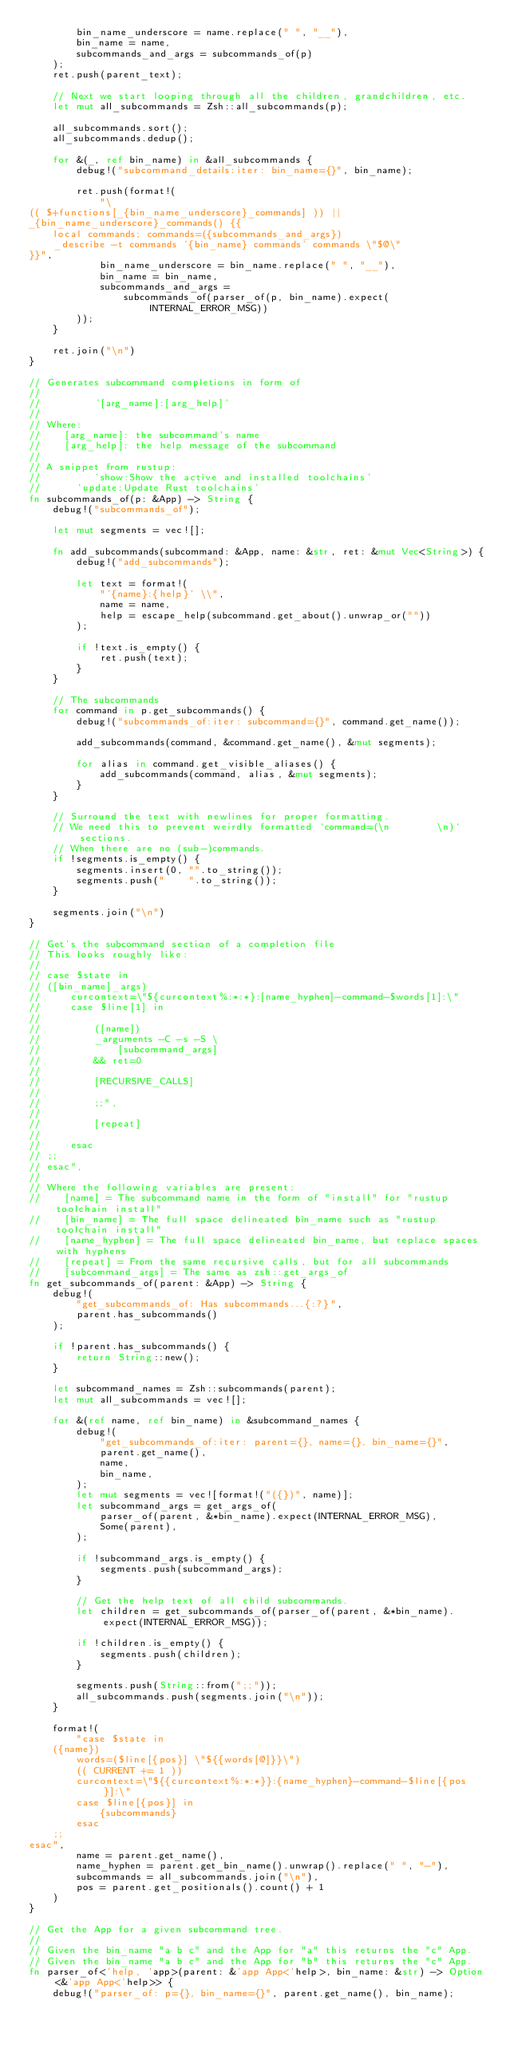Convert code to text. <code><loc_0><loc_0><loc_500><loc_500><_Rust_>        bin_name_underscore = name.replace(" ", "__"),
        bin_name = name,
        subcommands_and_args = subcommands_of(p)
    );
    ret.push(parent_text);

    // Next we start looping through all the children, grandchildren, etc.
    let mut all_subcommands = Zsh::all_subcommands(p);

    all_subcommands.sort();
    all_subcommands.dedup();

    for &(_, ref bin_name) in &all_subcommands {
        debug!("subcommand_details:iter: bin_name={}", bin_name);

        ret.push(format!(
            "\
(( $+functions[_{bin_name_underscore}_commands] )) ||
_{bin_name_underscore}_commands() {{
    local commands; commands=({subcommands_and_args})
    _describe -t commands '{bin_name} commands' commands \"$@\"
}}",
            bin_name_underscore = bin_name.replace(" ", "__"),
            bin_name = bin_name,
            subcommands_and_args =
                subcommands_of(parser_of(p, bin_name).expect(INTERNAL_ERROR_MSG))
        ));
    }

    ret.join("\n")
}

// Generates subcommand completions in form of
//
//         '[arg_name]:[arg_help]'
//
// Where:
//    [arg_name]: the subcommand's name
//    [arg_help]: the help message of the subcommand
//
// A snippet from rustup:
//         'show:Show the active and installed toolchains'
//      'update:Update Rust toolchains'
fn subcommands_of(p: &App) -> String {
    debug!("subcommands_of");

    let mut segments = vec![];

    fn add_subcommands(subcommand: &App, name: &str, ret: &mut Vec<String>) {
        debug!("add_subcommands");

        let text = format!(
            "'{name}:{help}' \\",
            name = name,
            help = escape_help(subcommand.get_about().unwrap_or(""))
        );

        if !text.is_empty() {
            ret.push(text);
        }
    }

    // The subcommands
    for command in p.get_subcommands() {
        debug!("subcommands_of:iter: subcommand={}", command.get_name());

        add_subcommands(command, &command.get_name(), &mut segments);

        for alias in command.get_visible_aliases() {
            add_subcommands(command, alias, &mut segments);
        }
    }

    // Surround the text with newlines for proper formatting.
    // We need this to prevent weirdly formatted `command=(\n        \n)` sections.
    // When there are no (sub-)commands.
    if !segments.is_empty() {
        segments.insert(0, "".to_string());
        segments.push("    ".to_string());
    }

    segments.join("\n")
}

// Get's the subcommand section of a completion file
// This looks roughly like:
//
// case $state in
// ([bin_name]_args)
//     curcontext=\"${curcontext%:*:*}:[name_hyphen]-command-$words[1]:\"
//     case $line[1] in
//
//         ([name])
//         _arguments -C -s -S \
//             [subcommand_args]
//         && ret=0
//
//         [RECURSIVE_CALLS]
//
//         ;;",
//
//         [repeat]
//
//     esac
// ;;
// esac",
//
// Where the following variables are present:
//    [name] = The subcommand name in the form of "install" for "rustup toolchain install"
//    [bin_name] = The full space delineated bin_name such as "rustup toolchain install"
//    [name_hyphen] = The full space delineated bin_name, but replace spaces with hyphens
//    [repeat] = From the same recursive calls, but for all subcommands
//    [subcommand_args] = The same as zsh::get_args_of
fn get_subcommands_of(parent: &App) -> String {
    debug!(
        "get_subcommands_of: Has subcommands...{:?}",
        parent.has_subcommands()
    );

    if !parent.has_subcommands() {
        return String::new();
    }

    let subcommand_names = Zsh::subcommands(parent);
    let mut all_subcommands = vec![];

    for &(ref name, ref bin_name) in &subcommand_names {
        debug!(
            "get_subcommands_of:iter: parent={}, name={}, bin_name={}",
            parent.get_name(),
            name,
            bin_name,
        );
        let mut segments = vec![format!("({})", name)];
        let subcommand_args = get_args_of(
            parser_of(parent, &*bin_name).expect(INTERNAL_ERROR_MSG),
            Some(parent),
        );

        if !subcommand_args.is_empty() {
            segments.push(subcommand_args);
        }

        // Get the help text of all child subcommands.
        let children = get_subcommands_of(parser_of(parent, &*bin_name).expect(INTERNAL_ERROR_MSG));

        if !children.is_empty() {
            segments.push(children);
        }

        segments.push(String::from(";;"));
        all_subcommands.push(segments.join("\n"));
    }

    format!(
        "case $state in
    ({name})
        words=($line[{pos}] \"${{words[@]}}\")
        (( CURRENT += 1 ))
        curcontext=\"${{curcontext%:*:*}}:{name_hyphen}-command-$line[{pos}]:\"
        case $line[{pos}] in
            {subcommands}
        esac
    ;;
esac",
        name = parent.get_name(),
        name_hyphen = parent.get_bin_name().unwrap().replace(" ", "-"),
        subcommands = all_subcommands.join("\n"),
        pos = parent.get_positionals().count() + 1
    )
}

// Get the App for a given subcommand tree.
//
// Given the bin_name "a b c" and the App for "a" this returns the "c" App.
// Given the bin_name "a b c" and the App for "b" this returns the "c" App.
fn parser_of<'help, 'app>(parent: &'app App<'help>, bin_name: &str) -> Option<&'app App<'help>> {
    debug!("parser_of: p={}, bin_name={}", parent.get_name(), bin_name);
</code> 